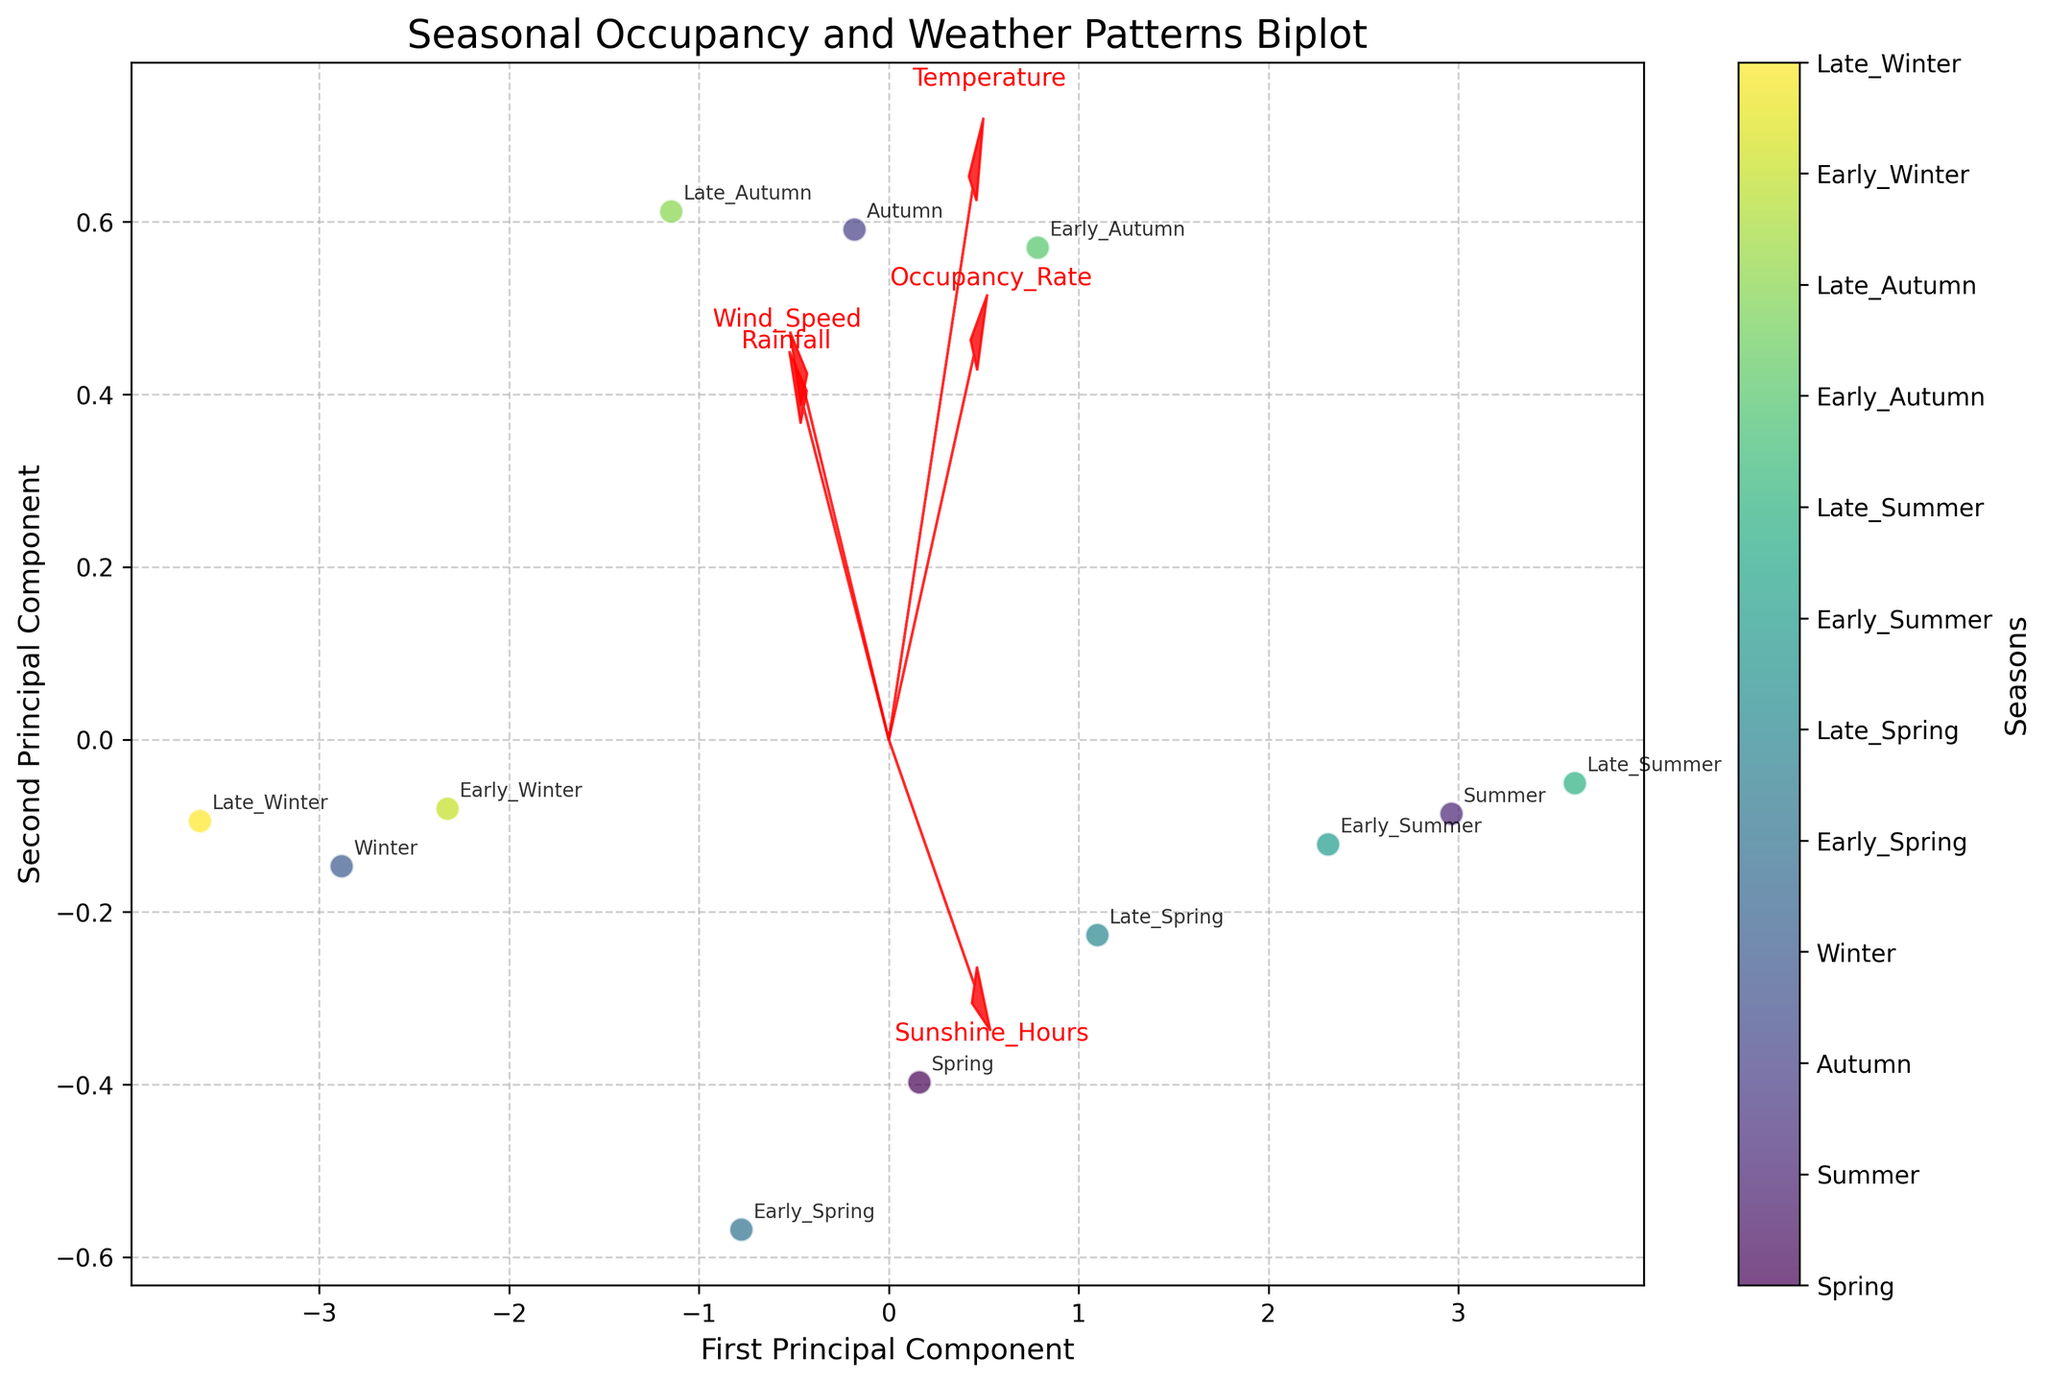What's the title of the plot? The title of the plot is usually located at the top center. In this case, the title is "Seasonal Occupancy and Weather Patterns Biplot."
Answer: Seasonal Occupancy and Weather Patterns Biplot How many data points are there in the plot? We count the number of data points plotted on the biplot. Each data point corresponds to a season segment. There are 12 seasons listed in the data, hence there must be 12 data points.
Answer: 12 What feature vector indicates the direction of increasing wind speed? In a biplot, feature vectors are represented by arrows. The arrow labeled "Wind_Speed" shows the direction of increasing wind speed.
Answer: The arrow labeled "Wind_Speed" Which season has the highest occupancy rate? The color bar and annotations on the plot can help identify seasons. The data point furthest in the positive direction along the "Occupancy_Rate" vector has the highest rate, which corresponds to "Late_Summer."
Answer: Late_Summer Which principal component (PC) has a larger influence on the variance in wind speed data? We can look at the projection of the "Wind_Speed" arrow. The PC that aligns more closely with the arrow direction has a larger influence. The "Wind_Speed" arrow has a larger projection on the second principal component.
Answer: Second Principal Component Compare the occupancy rates of "Early_Summer" and "Late_Winter." Which one is higher? Locate the data points for "Early_Summer" and "Late_Winter" as per the annotations and compare their positions along the "Occupancy_Rate" vector. The data point for "Early_Summer" is further in the positive direction along this vector, indicating a higher occupancy rate.
Answer: Early_Summer Does temperature have a significant impact on the first principal component? Check the length and direction of the "Temperature" vector in relation to the first principal component's axis. A longer arrow in this direction indicates a significant impact.
Answer: Yes Which season appears closest to the origin of the plot, indicating average values across features? Examine the locations of data points and identify the one nearest to the origin (0,0). This point corresponds to "Early_Winter."
Answer: Early_Winter What is the relationship between "Rainfall" and "Occupancy_Rate"? Look at the angles between the "Rainfall" and "Occupancy_Rate" vectors. A wide angle or nearly perpendicular vectors indicate a weak correlation.
Answer: Weak correlation 